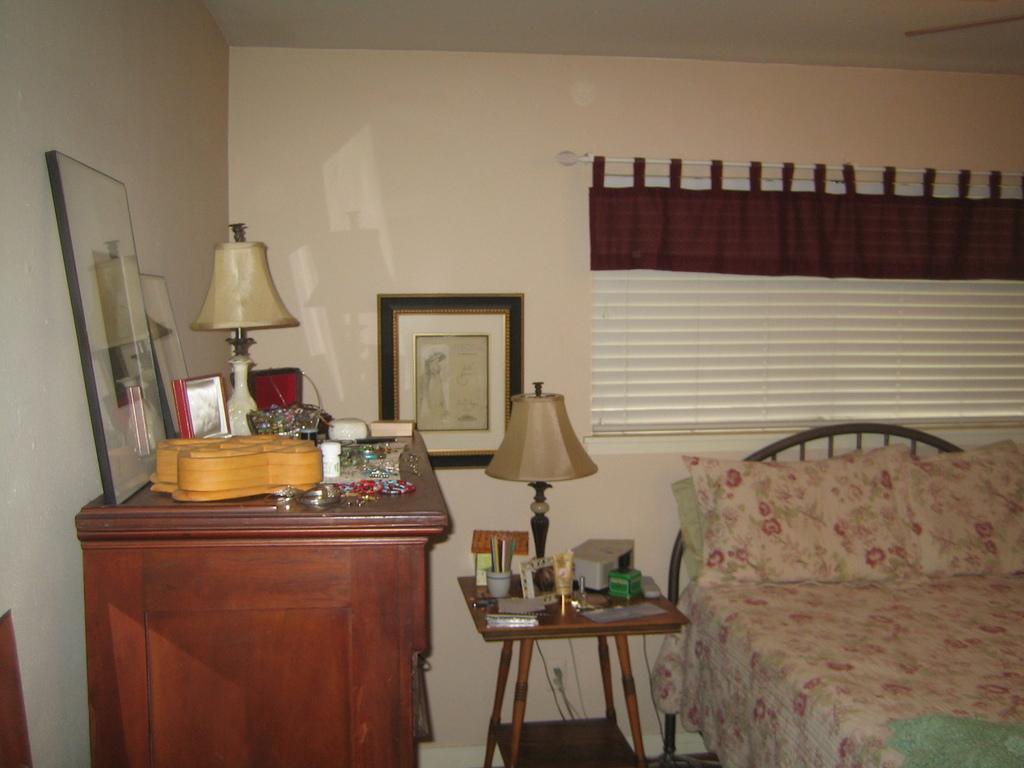How would you summarize this image in a sentence or two? This is an inside view of a bed room in which we can see a bed with some pillows and a lamp on a table. On the left side we can see a lamp and some photo frames on a cup board. On the backside we can see a wall and a curtain. 